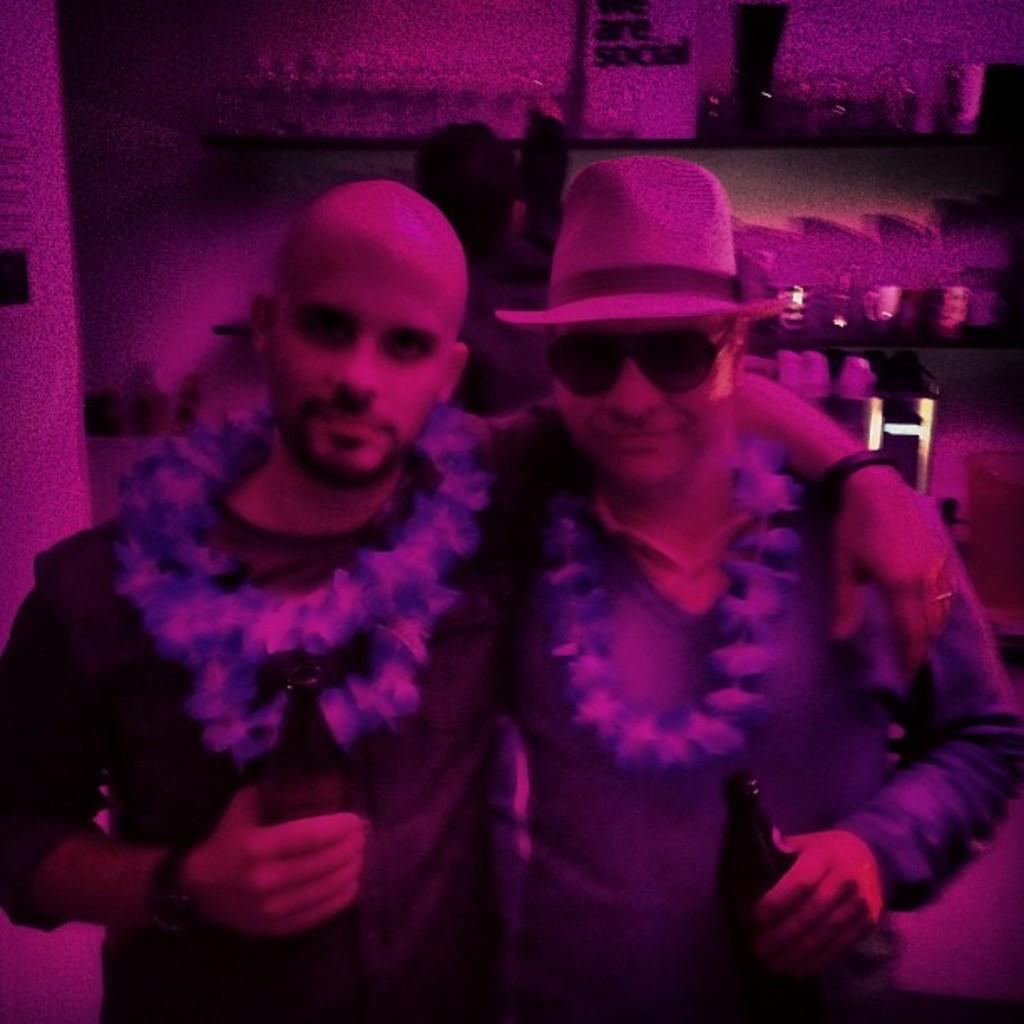How many people are in the image? There are two men in the image. What are the men holding in the image? Both men are holding bottles. Can you describe the appearance of the person on the right side of the image? The person on the right side of the image is wearing a cap and spectacles. What type of icicle can be seen hanging from the person's cap in the image? There is no icicle present in the image; the person on the right side of the image is wearing a cap, but there is no icicle mentioned or visible in the image. 